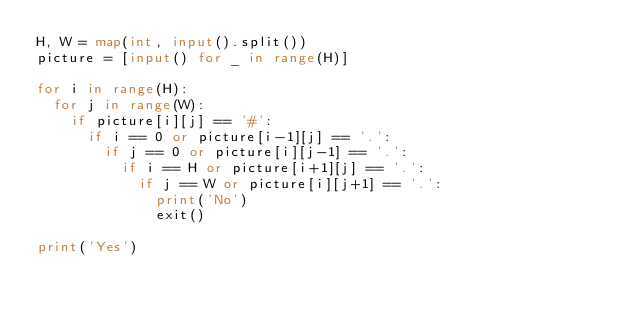<code> <loc_0><loc_0><loc_500><loc_500><_Python_>H, W = map(int, input().split())
picture = [input() for _ in range(H)]

for i in range(H):
	for j in range(W):
		if picture[i][j] == '#':
			if i == 0 or picture[i-1][j] == '.':
				if j == 0 or picture[i][j-1] == '.':
					if i == H or picture[i+1][j] == '.':
						if j == W or picture[i][j+1] == '.':
							print('No')
							exit()

print('Yes')
</code> 